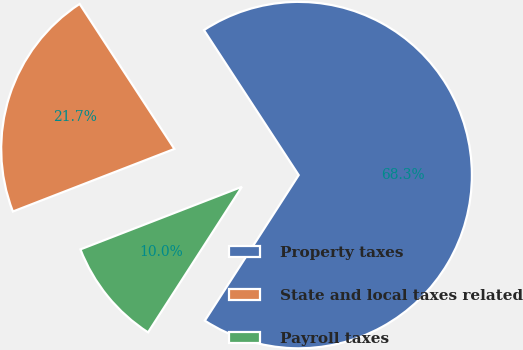Convert chart to OTSL. <chart><loc_0><loc_0><loc_500><loc_500><pie_chart><fcel>Property taxes<fcel>State and local taxes related<fcel>Payroll taxes<nl><fcel>68.33%<fcel>21.67%<fcel>10.0%<nl></chart> 